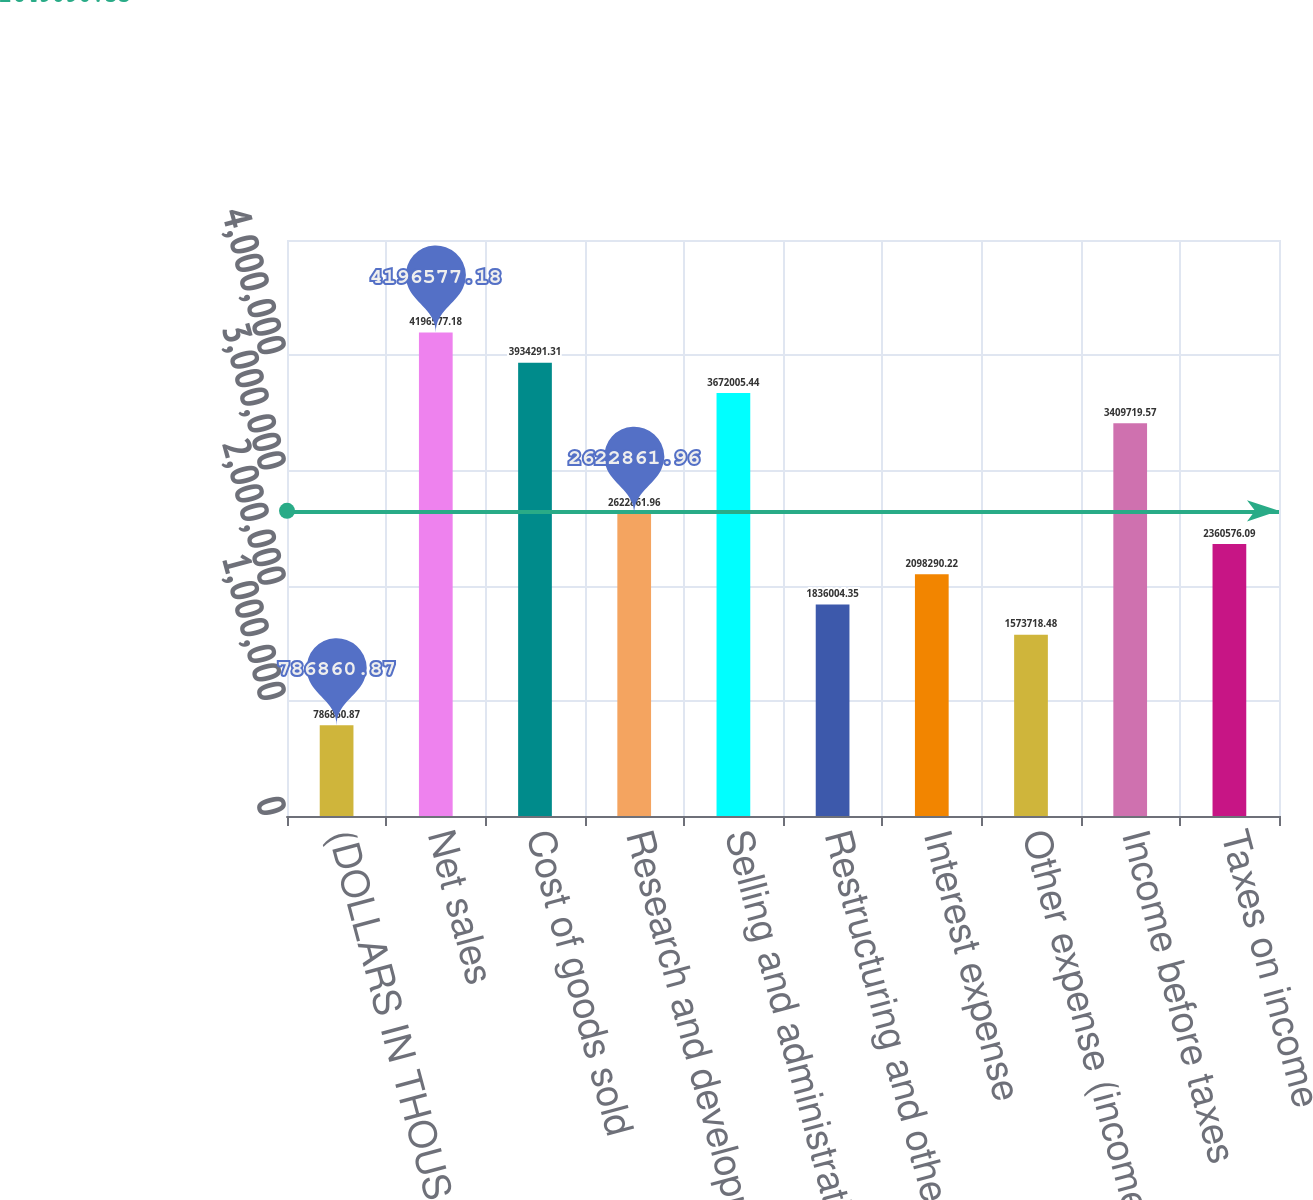Convert chart to OTSL. <chart><loc_0><loc_0><loc_500><loc_500><bar_chart><fcel>(DOLLARS IN THOUSANDS EXCEPT<fcel>Net sales<fcel>Cost of goods sold<fcel>Research and development<fcel>Selling and administrative<fcel>Restructuring and other<fcel>Interest expense<fcel>Other expense (income) net<fcel>Income before taxes<fcel>Taxes on income<nl><fcel>786861<fcel>4.19658e+06<fcel>3.93429e+06<fcel>2.62286e+06<fcel>3.67201e+06<fcel>1.836e+06<fcel>2.09829e+06<fcel>1.57372e+06<fcel>3.40972e+06<fcel>2.36058e+06<nl></chart> 